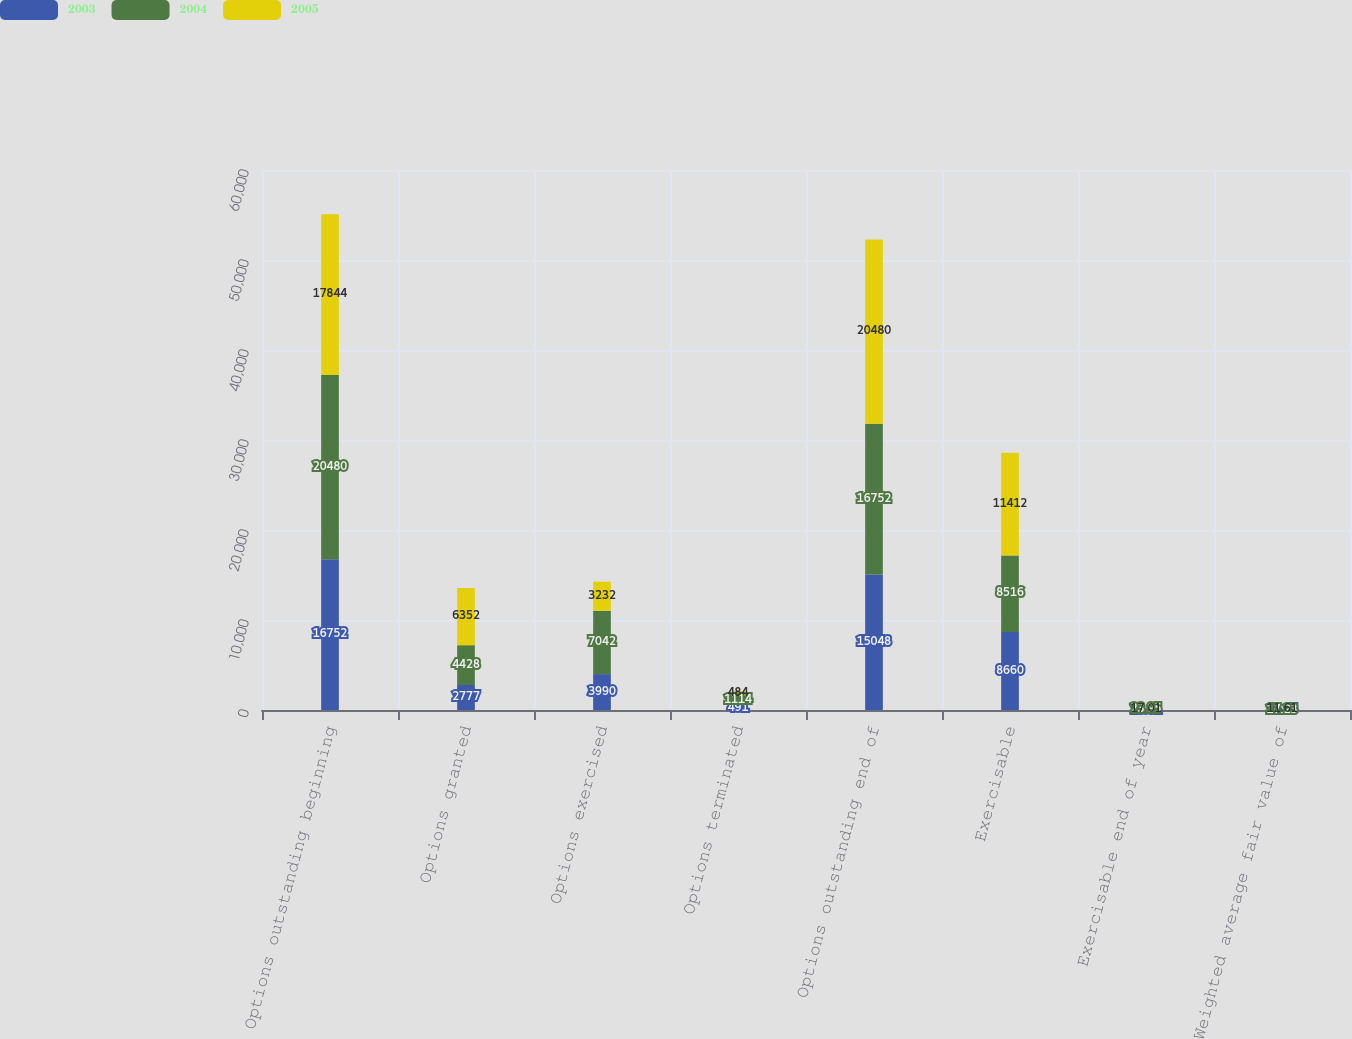<chart> <loc_0><loc_0><loc_500><loc_500><stacked_bar_chart><ecel><fcel>Options outstanding beginning<fcel>Options granted<fcel>Options exercised<fcel>Options terminated<fcel>Options outstanding end of<fcel>Exercisable<fcel>Exercisable end of year<fcel>Weighted average fair value of<nl><fcel>2003<fcel>16752<fcel>2777<fcel>3990<fcel>491<fcel>15048<fcel>8660<fcel>28.81<fcel>14.15<nl><fcel>2004<fcel>20480<fcel>4428<fcel>7042<fcel>1114<fcel>16752<fcel>8516<fcel>23.95<fcel>17.23<nl><fcel>2005<fcel>17844<fcel>6352<fcel>3232<fcel>484<fcel>20480<fcel>11412<fcel>17.01<fcel>11.61<nl></chart> 